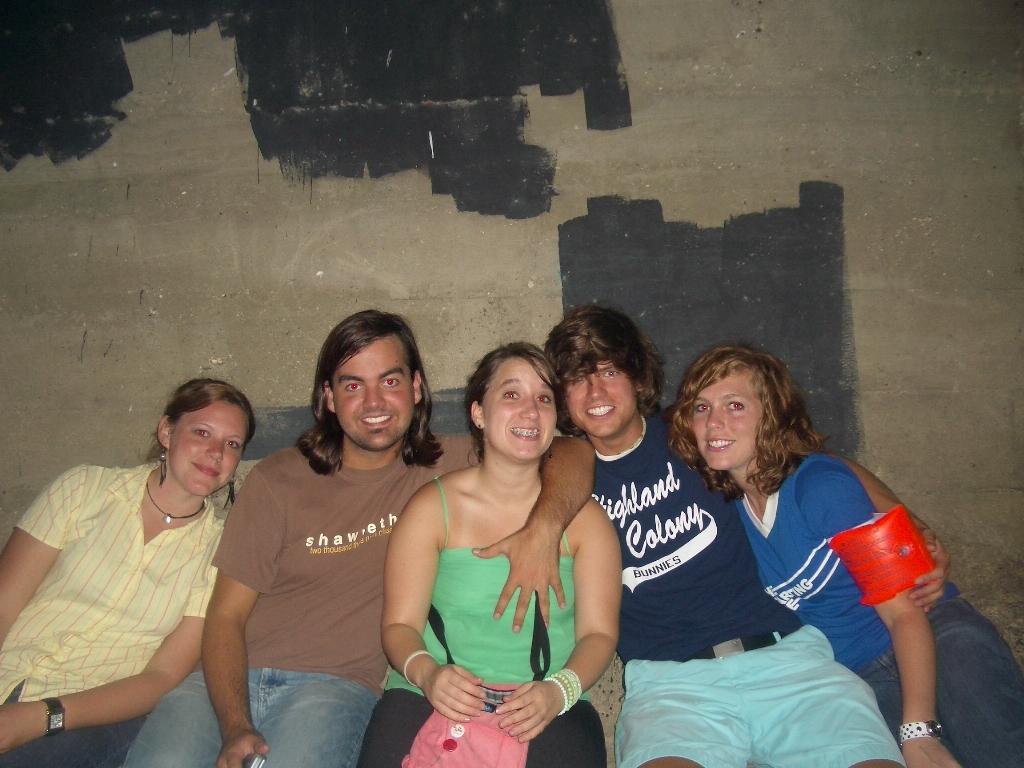Can you describe this image briefly? In this image we can see a few people, behind them, we can see the wall, there is the black paint on some areas of the wall. 